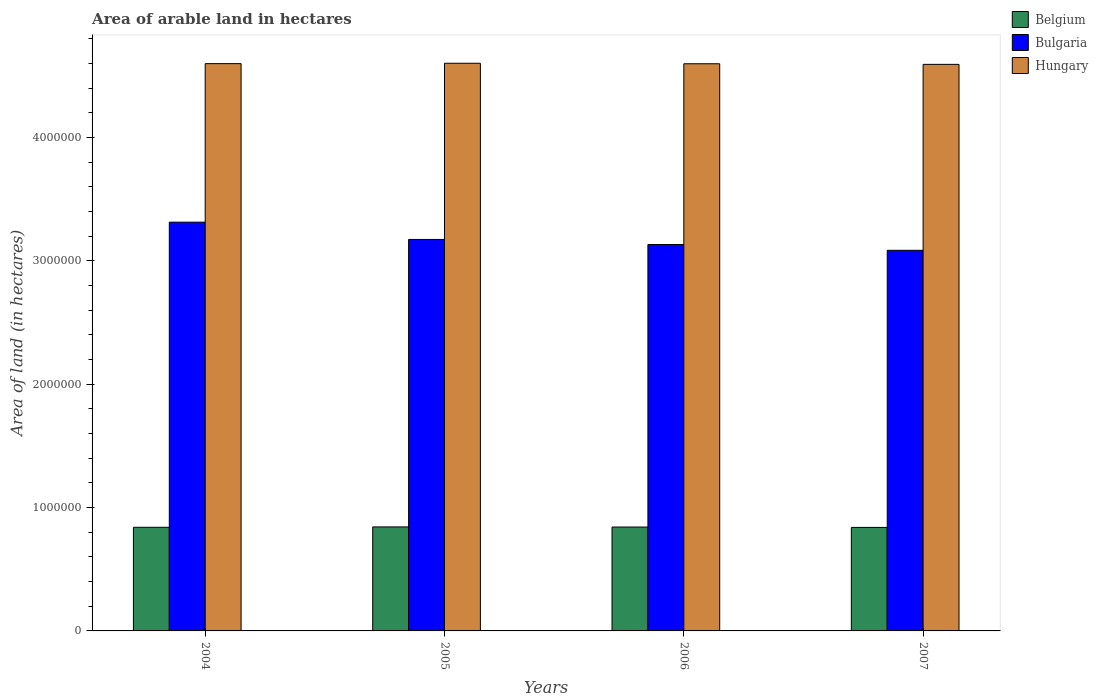How many different coloured bars are there?
Give a very brief answer. 3. How many bars are there on the 2nd tick from the left?
Give a very brief answer. 3. In how many cases, is the number of bars for a given year not equal to the number of legend labels?
Your response must be concise. 0. What is the total arable land in Belgium in 2004?
Offer a very short reply. 8.40e+05. Across all years, what is the maximum total arable land in Hungary?
Your response must be concise. 4.60e+06. Across all years, what is the minimum total arable land in Hungary?
Provide a short and direct response. 4.59e+06. What is the total total arable land in Bulgaria in the graph?
Offer a very short reply. 1.27e+07. What is the difference between the total arable land in Belgium in 2005 and the total arable land in Bulgaria in 2006?
Give a very brief answer. -2.29e+06. What is the average total arable land in Hungary per year?
Ensure brevity in your answer.  4.60e+06. In the year 2005, what is the difference between the total arable land in Belgium and total arable land in Bulgaria?
Offer a very short reply. -2.33e+06. What is the ratio of the total arable land in Bulgaria in 2005 to that in 2006?
Your answer should be compact. 1.01. What is the difference between the highest and the second highest total arable land in Hungary?
Your response must be concise. 3000. What is the difference between the highest and the lowest total arable land in Bulgaria?
Give a very brief answer. 2.28e+05. Is the sum of the total arable land in Belgium in 2005 and 2006 greater than the maximum total arable land in Bulgaria across all years?
Offer a terse response. No. What does the 3rd bar from the right in 2006 represents?
Keep it short and to the point. Belgium. Is it the case that in every year, the sum of the total arable land in Bulgaria and total arable land in Hungary is greater than the total arable land in Belgium?
Give a very brief answer. Yes. How many bars are there?
Make the answer very short. 12. Are all the bars in the graph horizontal?
Give a very brief answer. No. Does the graph contain any zero values?
Your answer should be compact. No. Does the graph contain grids?
Offer a very short reply. No. Where does the legend appear in the graph?
Ensure brevity in your answer.  Top right. What is the title of the graph?
Offer a terse response. Area of arable land in hectares. What is the label or title of the Y-axis?
Your answer should be very brief. Area of land (in hectares). What is the Area of land (in hectares) of Belgium in 2004?
Offer a very short reply. 8.40e+05. What is the Area of land (in hectares) in Bulgaria in 2004?
Make the answer very short. 3.31e+06. What is the Area of land (in hectares) in Hungary in 2004?
Provide a succinct answer. 4.60e+06. What is the Area of land (in hectares) in Belgium in 2005?
Ensure brevity in your answer.  8.43e+05. What is the Area of land (in hectares) in Bulgaria in 2005?
Your answer should be compact. 3.17e+06. What is the Area of land (in hectares) of Hungary in 2005?
Ensure brevity in your answer.  4.60e+06. What is the Area of land (in hectares) in Belgium in 2006?
Your answer should be very brief. 8.42e+05. What is the Area of land (in hectares) in Bulgaria in 2006?
Offer a very short reply. 3.13e+06. What is the Area of land (in hectares) in Hungary in 2006?
Provide a succinct answer. 4.60e+06. What is the Area of land (in hectares) in Belgium in 2007?
Provide a succinct answer. 8.39e+05. What is the Area of land (in hectares) in Bulgaria in 2007?
Your response must be concise. 3.08e+06. What is the Area of land (in hectares) of Hungary in 2007?
Your response must be concise. 4.59e+06. Across all years, what is the maximum Area of land (in hectares) in Belgium?
Ensure brevity in your answer.  8.43e+05. Across all years, what is the maximum Area of land (in hectares) of Bulgaria?
Ensure brevity in your answer.  3.31e+06. Across all years, what is the maximum Area of land (in hectares) in Hungary?
Ensure brevity in your answer.  4.60e+06. Across all years, what is the minimum Area of land (in hectares) in Belgium?
Your response must be concise. 8.39e+05. Across all years, what is the minimum Area of land (in hectares) in Bulgaria?
Provide a short and direct response. 3.08e+06. Across all years, what is the minimum Area of land (in hectares) of Hungary?
Give a very brief answer. 4.59e+06. What is the total Area of land (in hectares) of Belgium in the graph?
Provide a short and direct response. 3.36e+06. What is the total Area of land (in hectares) of Bulgaria in the graph?
Make the answer very short. 1.27e+07. What is the total Area of land (in hectares) of Hungary in the graph?
Provide a succinct answer. 1.84e+07. What is the difference between the Area of land (in hectares) in Belgium in 2004 and that in 2005?
Offer a terse response. -3000. What is the difference between the Area of land (in hectares) of Hungary in 2004 and that in 2005?
Ensure brevity in your answer.  -3000. What is the difference between the Area of land (in hectares) in Belgium in 2004 and that in 2006?
Ensure brevity in your answer.  -2000. What is the difference between the Area of land (in hectares) in Bulgaria in 2004 and that in 2006?
Give a very brief answer. 1.81e+05. What is the difference between the Area of land (in hectares) of Bulgaria in 2004 and that in 2007?
Provide a succinct answer. 2.28e+05. What is the difference between the Area of land (in hectares) of Hungary in 2004 and that in 2007?
Give a very brief answer. 6000. What is the difference between the Area of land (in hectares) in Belgium in 2005 and that in 2006?
Your answer should be very brief. 1000. What is the difference between the Area of land (in hectares) of Bulgaria in 2005 and that in 2006?
Provide a succinct answer. 4.10e+04. What is the difference between the Area of land (in hectares) in Hungary in 2005 and that in 2006?
Provide a short and direct response. 4000. What is the difference between the Area of land (in hectares) in Belgium in 2005 and that in 2007?
Offer a terse response. 4000. What is the difference between the Area of land (in hectares) of Bulgaria in 2005 and that in 2007?
Give a very brief answer. 8.80e+04. What is the difference between the Area of land (in hectares) of Hungary in 2005 and that in 2007?
Make the answer very short. 9000. What is the difference between the Area of land (in hectares) of Belgium in 2006 and that in 2007?
Your answer should be very brief. 3000. What is the difference between the Area of land (in hectares) of Bulgaria in 2006 and that in 2007?
Make the answer very short. 4.70e+04. What is the difference between the Area of land (in hectares) in Belgium in 2004 and the Area of land (in hectares) in Bulgaria in 2005?
Offer a terse response. -2.33e+06. What is the difference between the Area of land (in hectares) in Belgium in 2004 and the Area of land (in hectares) in Hungary in 2005?
Your response must be concise. -3.76e+06. What is the difference between the Area of land (in hectares) in Bulgaria in 2004 and the Area of land (in hectares) in Hungary in 2005?
Your response must be concise. -1.29e+06. What is the difference between the Area of land (in hectares) of Belgium in 2004 and the Area of land (in hectares) of Bulgaria in 2006?
Keep it short and to the point. -2.29e+06. What is the difference between the Area of land (in hectares) in Belgium in 2004 and the Area of land (in hectares) in Hungary in 2006?
Offer a very short reply. -3.76e+06. What is the difference between the Area of land (in hectares) of Bulgaria in 2004 and the Area of land (in hectares) of Hungary in 2006?
Provide a short and direct response. -1.28e+06. What is the difference between the Area of land (in hectares) in Belgium in 2004 and the Area of land (in hectares) in Bulgaria in 2007?
Offer a terse response. -2.24e+06. What is the difference between the Area of land (in hectares) in Belgium in 2004 and the Area of land (in hectares) in Hungary in 2007?
Offer a very short reply. -3.75e+06. What is the difference between the Area of land (in hectares) of Bulgaria in 2004 and the Area of land (in hectares) of Hungary in 2007?
Give a very brief answer. -1.28e+06. What is the difference between the Area of land (in hectares) in Belgium in 2005 and the Area of land (in hectares) in Bulgaria in 2006?
Your answer should be compact. -2.29e+06. What is the difference between the Area of land (in hectares) in Belgium in 2005 and the Area of land (in hectares) in Hungary in 2006?
Keep it short and to the point. -3.75e+06. What is the difference between the Area of land (in hectares) in Bulgaria in 2005 and the Area of land (in hectares) in Hungary in 2006?
Provide a short and direct response. -1.42e+06. What is the difference between the Area of land (in hectares) in Belgium in 2005 and the Area of land (in hectares) in Bulgaria in 2007?
Ensure brevity in your answer.  -2.24e+06. What is the difference between the Area of land (in hectares) in Belgium in 2005 and the Area of land (in hectares) in Hungary in 2007?
Your answer should be very brief. -3.75e+06. What is the difference between the Area of land (in hectares) of Bulgaria in 2005 and the Area of land (in hectares) of Hungary in 2007?
Your response must be concise. -1.42e+06. What is the difference between the Area of land (in hectares) in Belgium in 2006 and the Area of land (in hectares) in Bulgaria in 2007?
Your response must be concise. -2.24e+06. What is the difference between the Area of land (in hectares) in Belgium in 2006 and the Area of land (in hectares) in Hungary in 2007?
Your response must be concise. -3.75e+06. What is the difference between the Area of land (in hectares) of Bulgaria in 2006 and the Area of land (in hectares) of Hungary in 2007?
Provide a short and direct response. -1.46e+06. What is the average Area of land (in hectares) in Belgium per year?
Keep it short and to the point. 8.41e+05. What is the average Area of land (in hectares) of Bulgaria per year?
Ensure brevity in your answer.  3.18e+06. What is the average Area of land (in hectares) in Hungary per year?
Give a very brief answer. 4.60e+06. In the year 2004, what is the difference between the Area of land (in hectares) in Belgium and Area of land (in hectares) in Bulgaria?
Make the answer very short. -2.47e+06. In the year 2004, what is the difference between the Area of land (in hectares) in Belgium and Area of land (in hectares) in Hungary?
Offer a terse response. -3.76e+06. In the year 2004, what is the difference between the Area of land (in hectares) of Bulgaria and Area of land (in hectares) of Hungary?
Provide a short and direct response. -1.28e+06. In the year 2005, what is the difference between the Area of land (in hectares) of Belgium and Area of land (in hectares) of Bulgaria?
Your answer should be compact. -2.33e+06. In the year 2005, what is the difference between the Area of land (in hectares) in Belgium and Area of land (in hectares) in Hungary?
Provide a succinct answer. -3.76e+06. In the year 2005, what is the difference between the Area of land (in hectares) of Bulgaria and Area of land (in hectares) of Hungary?
Provide a short and direct response. -1.43e+06. In the year 2006, what is the difference between the Area of land (in hectares) of Belgium and Area of land (in hectares) of Bulgaria?
Your answer should be very brief. -2.29e+06. In the year 2006, what is the difference between the Area of land (in hectares) of Belgium and Area of land (in hectares) of Hungary?
Ensure brevity in your answer.  -3.76e+06. In the year 2006, what is the difference between the Area of land (in hectares) in Bulgaria and Area of land (in hectares) in Hungary?
Ensure brevity in your answer.  -1.46e+06. In the year 2007, what is the difference between the Area of land (in hectares) of Belgium and Area of land (in hectares) of Bulgaria?
Provide a succinct answer. -2.25e+06. In the year 2007, what is the difference between the Area of land (in hectares) in Belgium and Area of land (in hectares) in Hungary?
Make the answer very short. -3.75e+06. In the year 2007, what is the difference between the Area of land (in hectares) of Bulgaria and Area of land (in hectares) of Hungary?
Offer a terse response. -1.51e+06. What is the ratio of the Area of land (in hectares) of Belgium in 2004 to that in 2005?
Give a very brief answer. 1. What is the ratio of the Area of land (in hectares) of Bulgaria in 2004 to that in 2005?
Keep it short and to the point. 1.04. What is the ratio of the Area of land (in hectares) of Hungary in 2004 to that in 2005?
Make the answer very short. 1. What is the ratio of the Area of land (in hectares) in Bulgaria in 2004 to that in 2006?
Your answer should be compact. 1.06. What is the ratio of the Area of land (in hectares) of Belgium in 2004 to that in 2007?
Offer a very short reply. 1. What is the ratio of the Area of land (in hectares) in Bulgaria in 2004 to that in 2007?
Provide a short and direct response. 1.07. What is the ratio of the Area of land (in hectares) in Hungary in 2004 to that in 2007?
Keep it short and to the point. 1. What is the ratio of the Area of land (in hectares) of Bulgaria in 2005 to that in 2006?
Your answer should be compact. 1.01. What is the ratio of the Area of land (in hectares) of Hungary in 2005 to that in 2006?
Your answer should be very brief. 1. What is the ratio of the Area of land (in hectares) in Bulgaria in 2005 to that in 2007?
Provide a short and direct response. 1.03. What is the ratio of the Area of land (in hectares) in Hungary in 2005 to that in 2007?
Make the answer very short. 1. What is the ratio of the Area of land (in hectares) of Bulgaria in 2006 to that in 2007?
Make the answer very short. 1.02. What is the difference between the highest and the second highest Area of land (in hectares) in Bulgaria?
Give a very brief answer. 1.40e+05. What is the difference between the highest and the second highest Area of land (in hectares) of Hungary?
Make the answer very short. 3000. What is the difference between the highest and the lowest Area of land (in hectares) of Belgium?
Ensure brevity in your answer.  4000. What is the difference between the highest and the lowest Area of land (in hectares) of Bulgaria?
Make the answer very short. 2.28e+05. What is the difference between the highest and the lowest Area of land (in hectares) in Hungary?
Ensure brevity in your answer.  9000. 